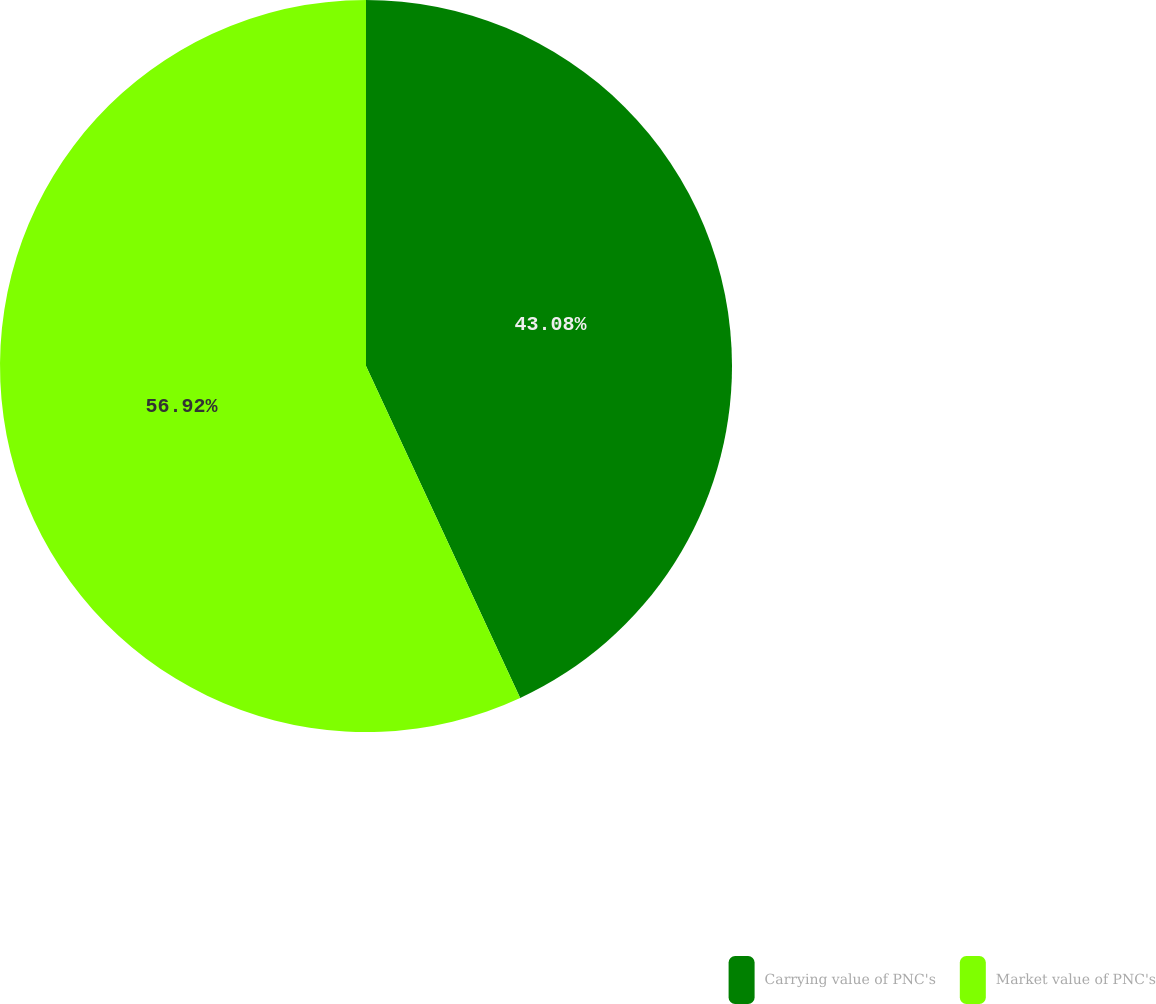Convert chart. <chart><loc_0><loc_0><loc_500><loc_500><pie_chart><fcel>Carrying value of PNC's<fcel>Market value of PNC's<nl><fcel>43.08%<fcel>56.92%<nl></chart> 